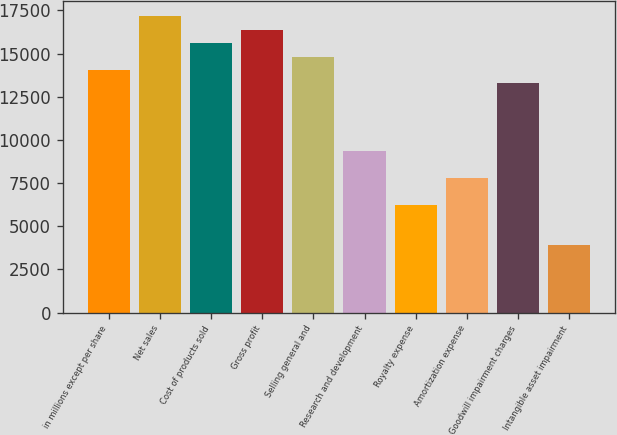Convert chart to OTSL. <chart><loc_0><loc_0><loc_500><loc_500><bar_chart><fcel>in millions except per share<fcel>Net sales<fcel>Cost of products sold<fcel>Gross profit<fcel>Selling general and<fcel>Research and development<fcel>Royalty expense<fcel>Amortization expense<fcel>Goodwill impairment charges<fcel>Intangible asset impairment<nl><fcel>14050.2<fcel>17172.4<fcel>15611.3<fcel>16391.8<fcel>14830.8<fcel>9367.06<fcel>6244.94<fcel>7806<fcel>13269.7<fcel>3903.35<nl></chart> 